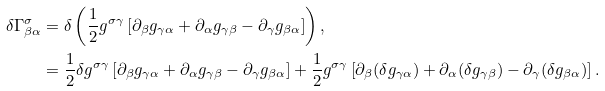Convert formula to latex. <formula><loc_0><loc_0><loc_500><loc_500>\delta \Gamma _ { \beta \alpha } ^ { \sigma } & = \delta \left ( \frac { 1 } { 2 } g ^ { \sigma \gamma } \left [ \partial _ { \beta } g _ { \gamma \alpha } + \partial _ { \alpha } g _ { \gamma \beta } - \partial _ { \gamma } g _ { \beta \alpha } \right ] \right ) , \\ & = \frac { 1 } { 2 } \delta g ^ { \sigma \gamma } \left [ \partial _ { \beta } g _ { \gamma \alpha } + \partial _ { \alpha } g _ { \gamma \beta } - \partial _ { \gamma } g _ { \beta \alpha } \right ] + \frac { 1 } { 2 } g ^ { \sigma \gamma } \left [ \partial _ { \beta } ( \delta g _ { \gamma \alpha } ) + \partial _ { \alpha } ( \delta g _ { \gamma \beta } ) - \partial _ { \gamma } ( \delta g _ { \beta \alpha } ) \right ] .</formula> 